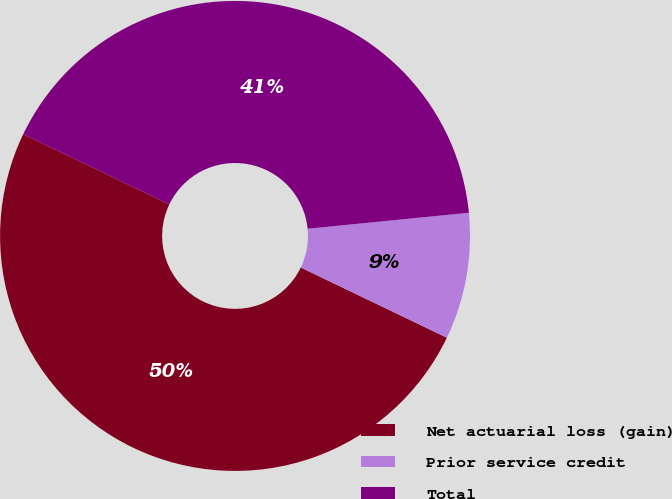Convert chart to OTSL. <chart><loc_0><loc_0><loc_500><loc_500><pie_chart><fcel>Net actuarial loss (gain)<fcel>Prior service credit<fcel>Total<nl><fcel>50.0%<fcel>8.7%<fcel>41.3%<nl></chart> 